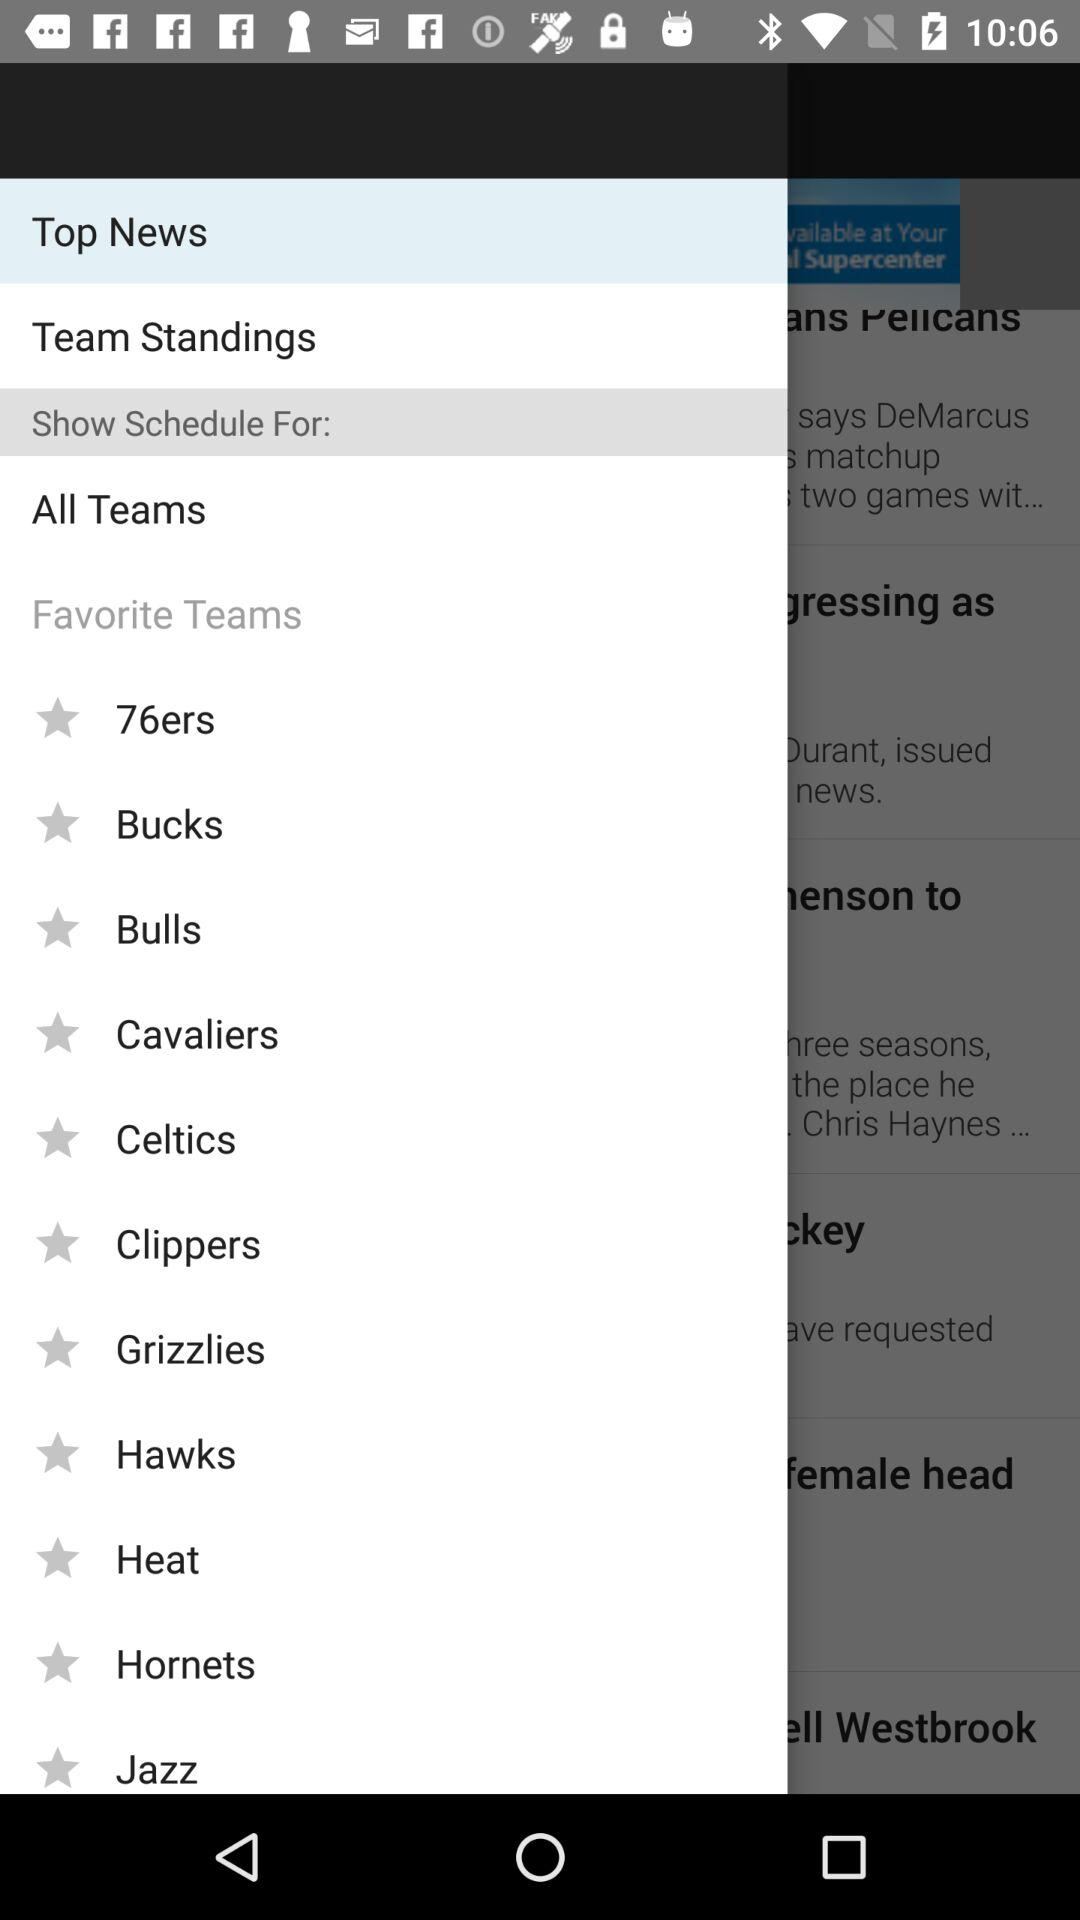What are the names of the available favorite teams? The names of the available favorite teams are "76ers", "Bucks", "Bulls", "Cavaliers", "Celtics", "Clippers", "Grizzlies", "Hawks", "Heat", "Hornets" and "Jazz". 